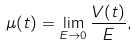Convert formula to latex. <formula><loc_0><loc_0><loc_500><loc_500>\mu ( t ) = \lim _ { E \to 0 } \frac { V ( t ) } { E } ,</formula> 